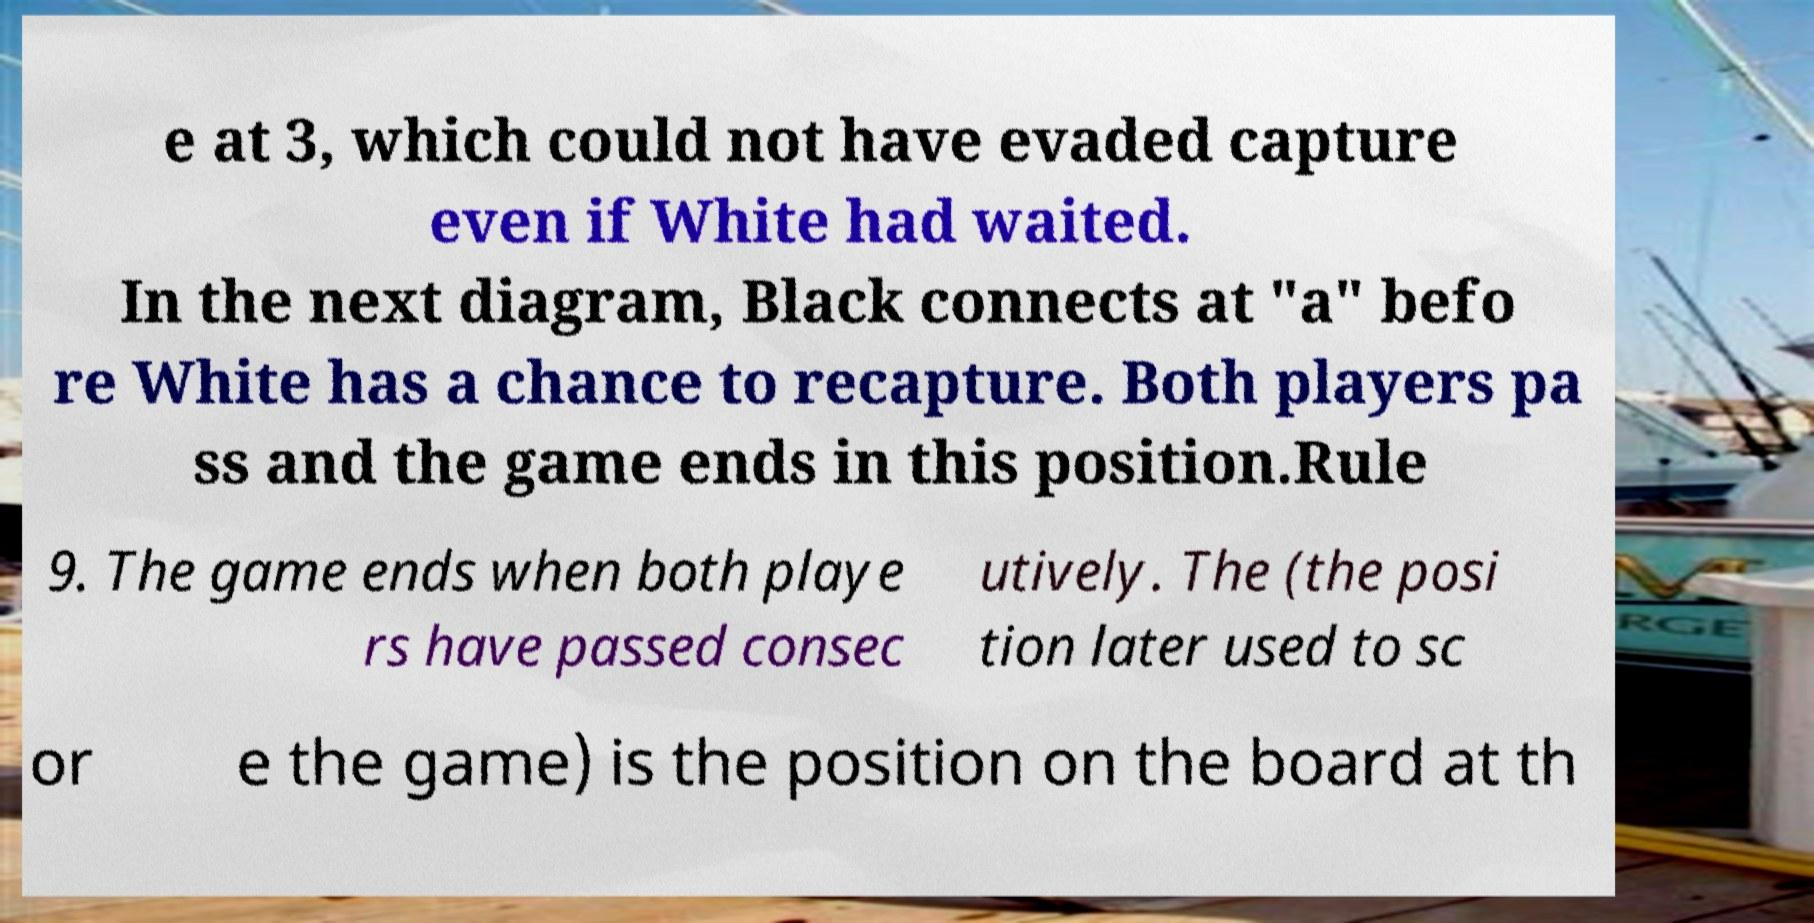There's text embedded in this image that I need extracted. Can you transcribe it verbatim? e at 3, which could not have evaded capture even if White had waited. In the next diagram, Black connects at "a" befo re White has a chance to recapture. Both players pa ss and the game ends in this position.Rule 9. The game ends when both playe rs have passed consec utively. The (the posi tion later used to sc or e the game) is the position on the board at th 